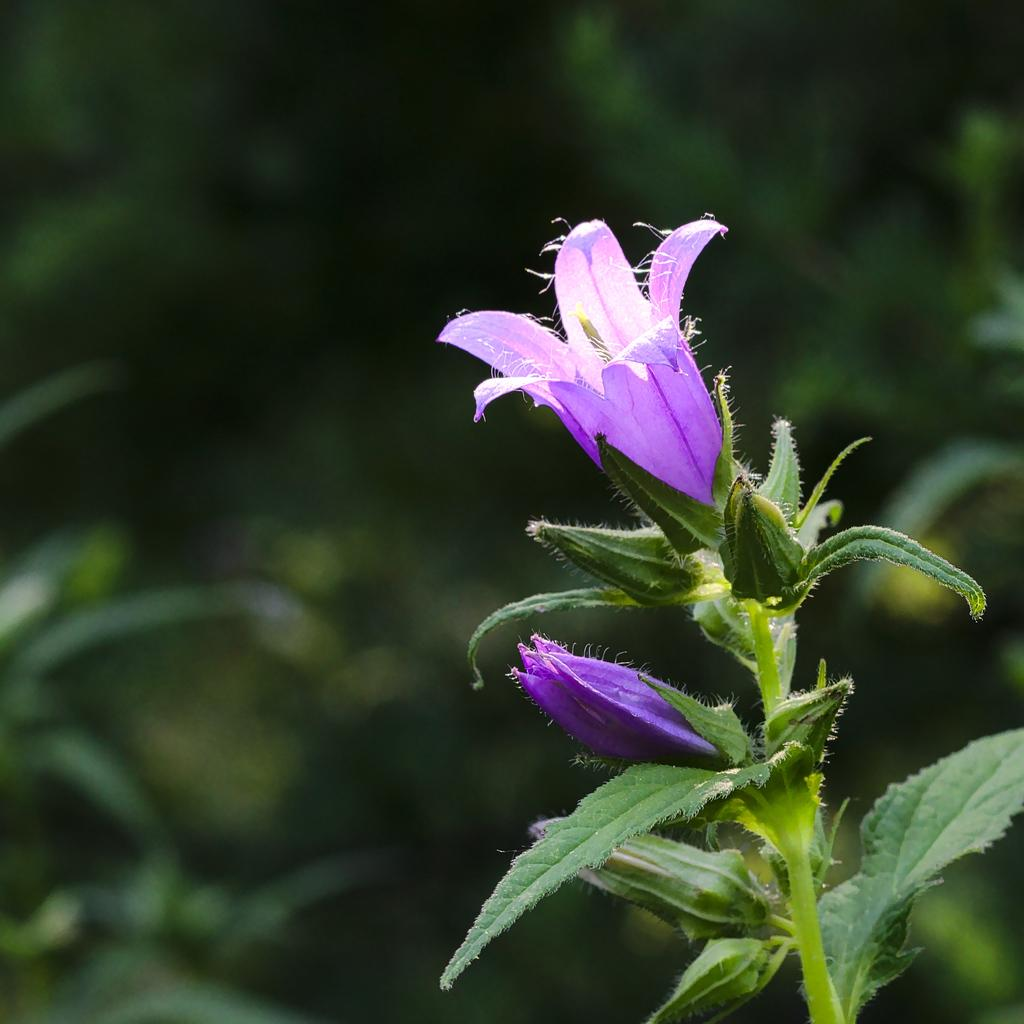What type of plant is visible on the right side of the image? There is a plant on the right side of the image. What colors are present on the plant? The plant has violet-colored flowers and green-colored leaves. How would you describe the background of the image? The background of the image is blurred. Can you tell me how many cats are playing in the band in the image? There are no cats or bands present in the image; it features a plant with violet-colored flowers and green-colored leaves against a blurred background. 